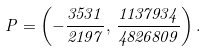Convert formula to latex. <formula><loc_0><loc_0><loc_500><loc_500>P = \left ( - \frac { 3 5 3 1 } { 2 1 9 7 } , \, \frac { 1 1 3 7 9 3 4 } { 4 8 2 6 8 0 9 } \right ) .</formula> 